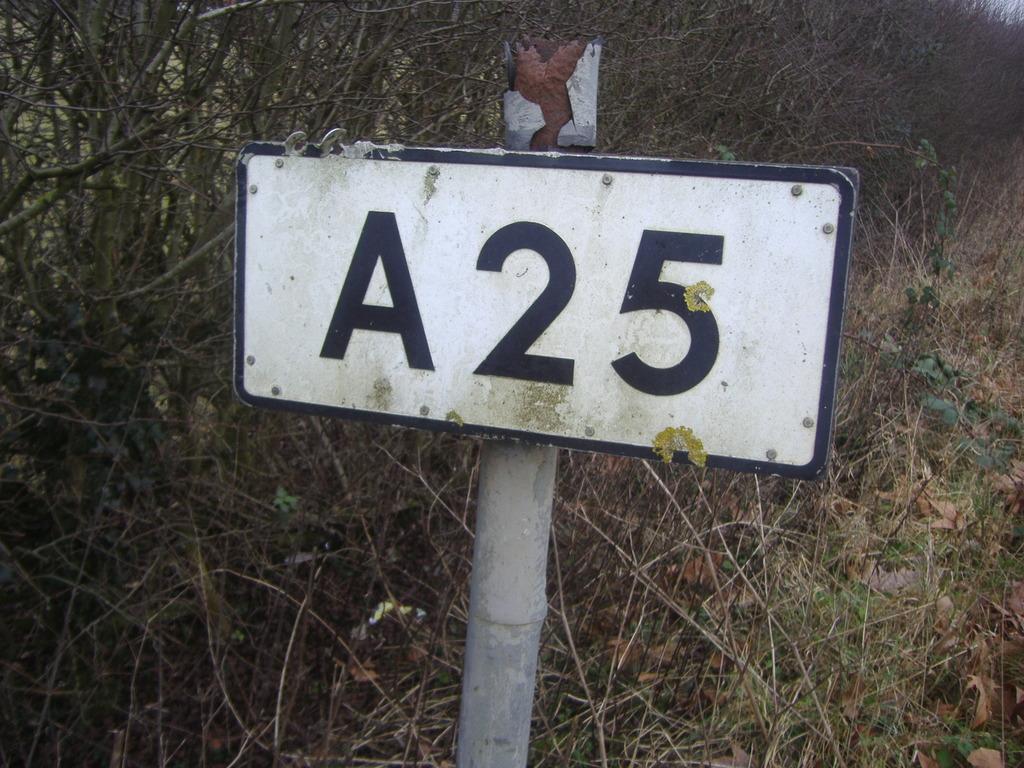A25 road sign?
Your response must be concise. Yes. 